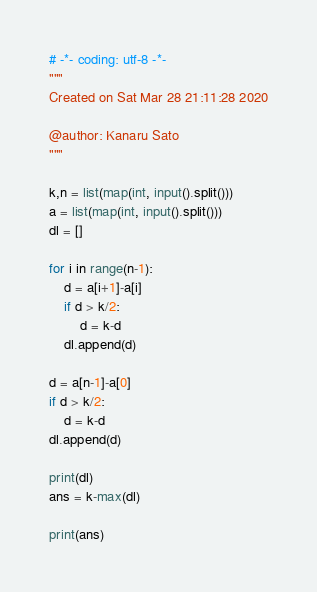<code> <loc_0><loc_0><loc_500><loc_500><_Python_># -*- coding: utf-8 -*-
"""
Created on Sat Mar 28 21:11:28 2020

@author: Kanaru Sato
"""

k,n = list(map(int, input().split()))
a = list(map(int, input().split()))
dl = []

for i in range(n-1):
    d = a[i+1]-a[i]
    if d > k/2:
        d = k-d
    dl.append(d)

d = a[n-1]-a[0]
if d > k/2:
    d = k-d
dl.append(d)

print(dl)
ans = k-max(dl)

print(ans)</code> 